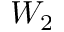<formula> <loc_0><loc_0><loc_500><loc_500>W _ { 2 }</formula> 